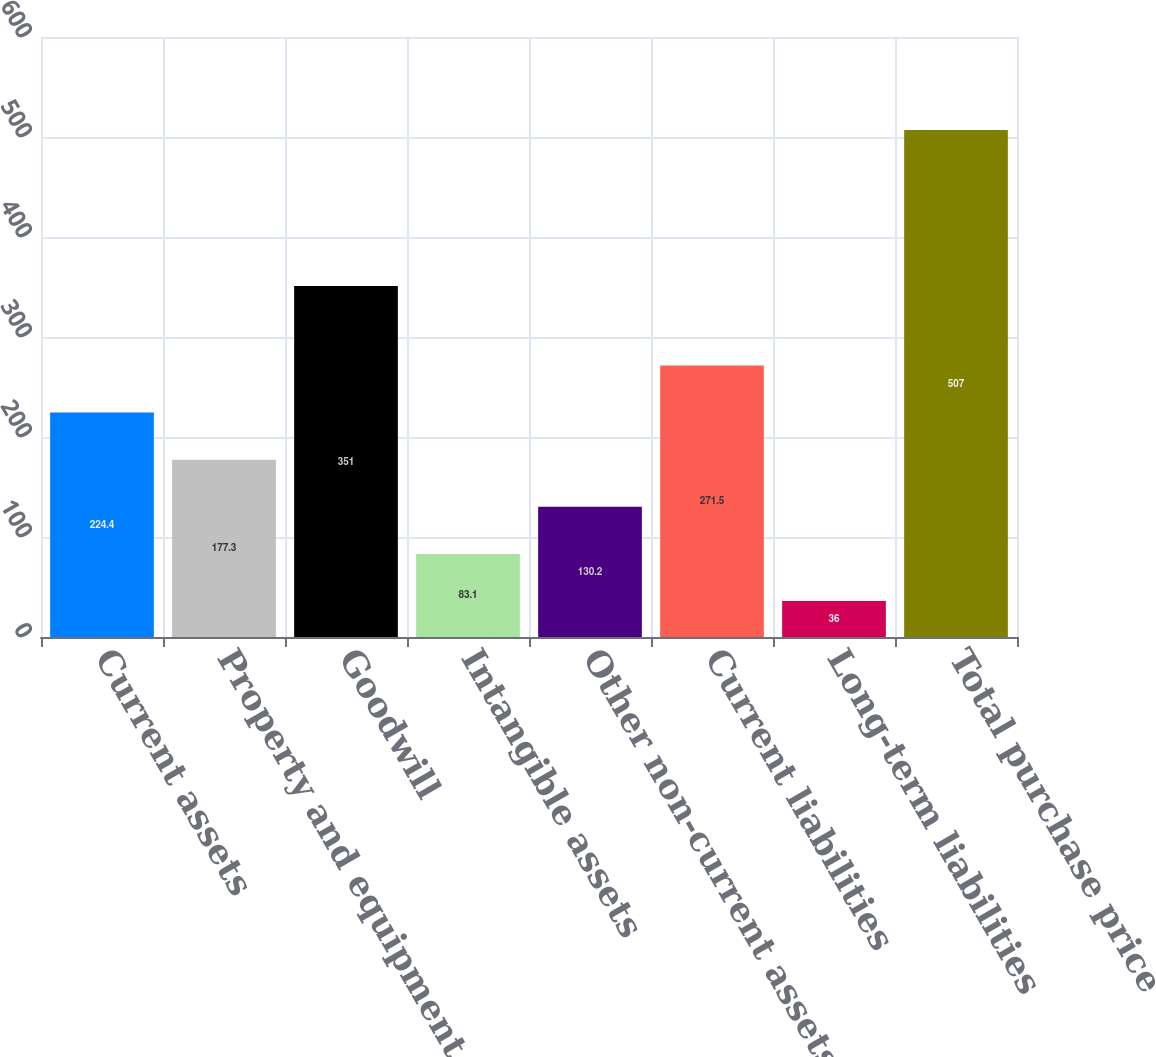Convert chart to OTSL. <chart><loc_0><loc_0><loc_500><loc_500><bar_chart><fcel>Current assets<fcel>Property and equipment<fcel>Goodwill<fcel>Intangible assets<fcel>Other non-current assets<fcel>Current liabilities<fcel>Long-term liabilities<fcel>Total purchase price<nl><fcel>224.4<fcel>177.3<fcel>351<fcel>83.1<fcel>130.2<fcel>271.5<fcel>36<fcel>507<nl></chart> 